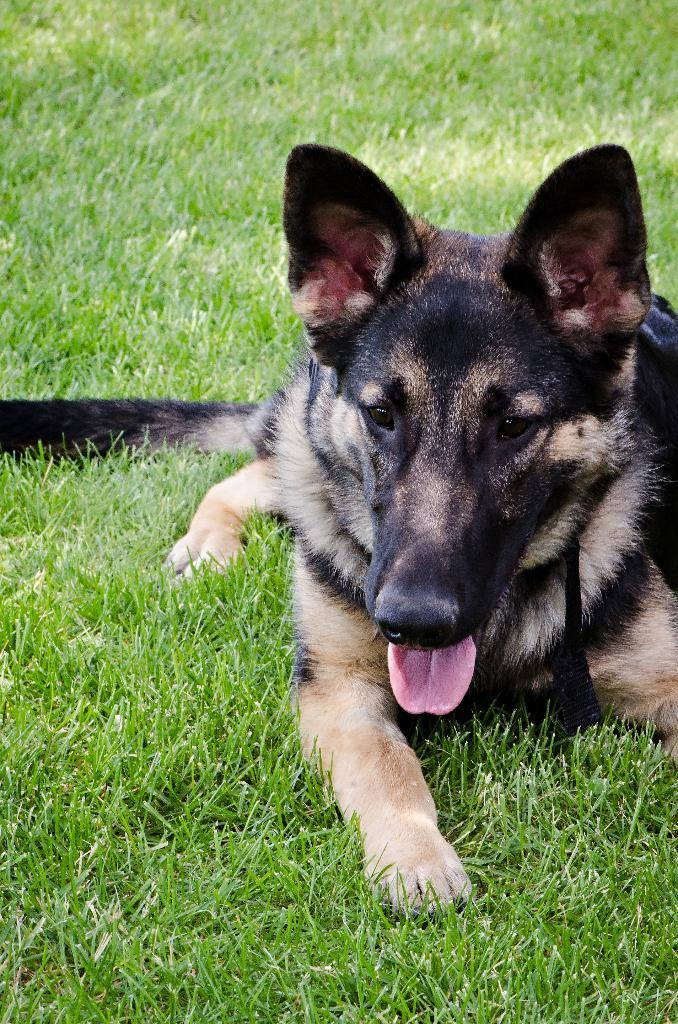What type of animal is in the image? There is a dog in the image. Where is the dog located? The dog is on the grass. What type of wax can be seen melting on the dog in the image? There is no wax present in the image; it features a dog on the grass. 